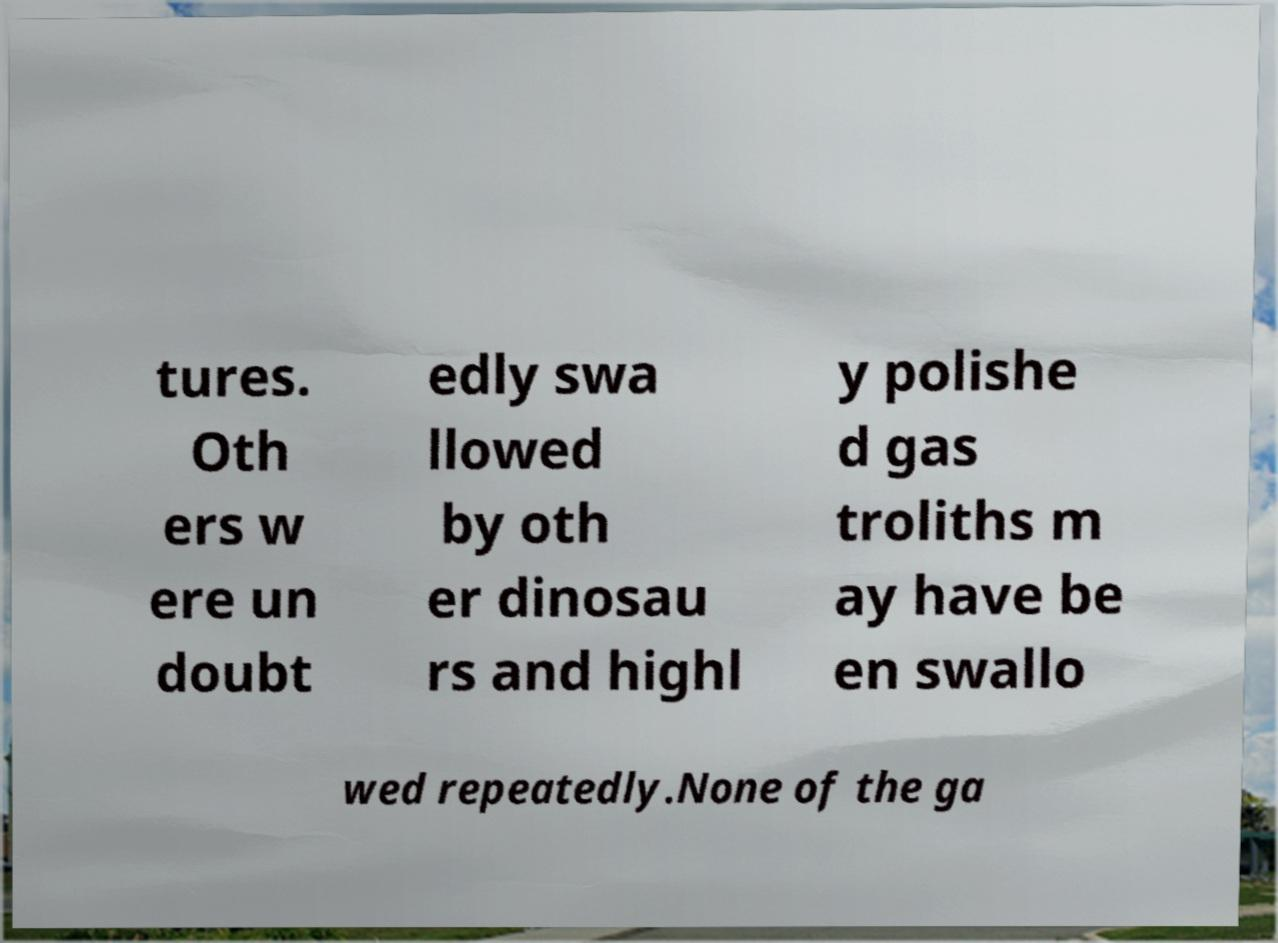Can you accurately transcribe the text from the provided image for me? tures. Oth ers w ere un doubt edly swa llowed by oth er dinosau rs and highl y polishe d gas troliths m ay have be en swallo wed repeatedly.None of the ga 